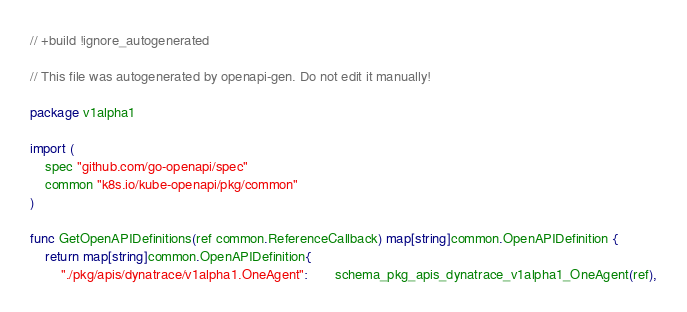Convert code to text. <code><loc_0><loc_0><loc_500><loc_500><_Go_>// +build !ignore_autogenerated

// This file was autogenerated by openapi-gen. Do not edit it manually!

package v1alpha1

import (
	spec "github.com/go-openapi/spec"
	common "k8s.io/kube-openapi/pkg/common"
)

func GetOpenAPIDefinitions(ref common.ReferenceCallback) map[string]common.OpenAPIDefinition {
	return map[string]common.OpenAPIDefinition{
		"./pkg/apis/dynatrace/v1alpha1.OneAgent":       schema_pkg_apis_dynatrace_v1alpha1_OneAgent(ref),</code> 